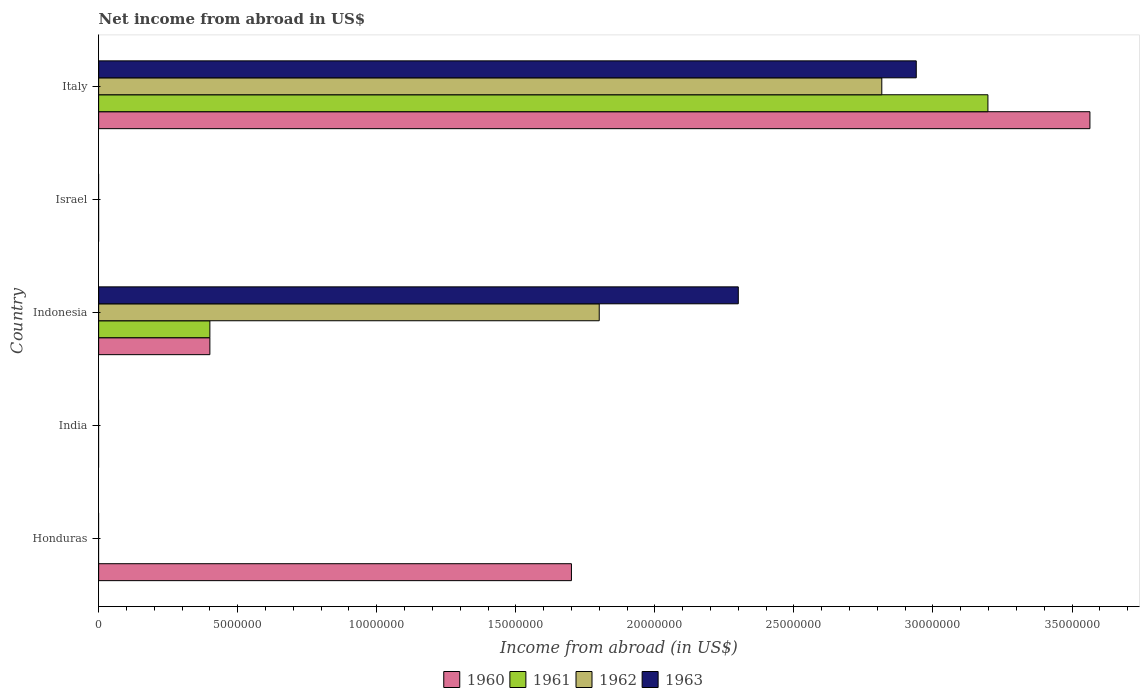Are the number of bars on each tick of the Y-axis equal?
Make the answer very short. No. How many bars are there on the 5th tick from the top?
Your answer should be very brief. 1. How many bars are there on the 1st tick from the bottom?
Your answer should be very brief. 1. What is the label of the 2nd group of bars from the top?
Offer a very short reply. Israel. In how many cases, is the number of bars for a given country not equal to the number of legend labels?
Ensure brevity in your answer.  3. What is the net income from abroad in 1961 in India?
Keep it short and to the point. 0. Across all countries, what is the maximum net income from abroad in 1963?
Make the answer very short. 2.94e+07. Across all countries, what is the minimum net income from abroad in 1961?
Make the answer very short. 0. In which country was the net income from abroad in 1960 maximum?
Ensure brevity in your answer.  Italy. What is the total net income from abroad in 1963 in the graph?
Provide a short and direct response. 5.24e+07. What is the difference between the net income from abroad in 1960 in India and the net income from abroad in 1963 in Indonesia?
Your response must be concise. -2.30e+07. What is the average net income from abroad in 1962 per country?
Provide a succinct answer. 9.23e+06. What is the difference between the net income from abroad in 1962 and net income from abroad in 1961 in Indonesia?
Your response must be concise. 1.40e+07. In how many countries, is the net income from abroad in 1963 greater than 11000000 US$?
Provide a short and direct response. 2. What is the difference between the highest and the second highest net income from abroad in 1960?
Your response must be concise. 1.86e+07. What is the difference between the highest and the lowest net income from abroad in 1961?
Make the answer very short. 3.20e+07. In how many countries, is the net income from abroad in 1960 greater than the average net income from abroad in 1960 taken over all countries?
Offer a very short reply. 2. Is the sum of the net income from abroad in 1960 in Honduras and Italy greater than the maximum net income from abroad in 1961 across all countries?
Make the answer very short. Yes. Is it the case that in every country, the sum of the net income from abroad in 1960 and net income from abroad in 1963 is greater than the net income from abroad in 1961?
Give a very brief answer. No. How many bars are there?
Provide a succinct answer. 9. How many countries are there in the graph?
Provide a succinct answer. 5. What is the difference between two consecutive major ticks on the X-axis?
Offer a very short reply. 5.00e+06. Are the values on the major ticks of X-axis written in scientific E-notation?
Provide a short and direct response. No. Does the graph contain grids?
Your response must be concise. No. Where does the legend appear in the graph?
Keep it short and to the point. Bottom center. How are the legend labels stacked?
Give a very brief answer. Horizontal. What is the title of the graph?
Give a very brief answer. Net income from abroad in US$. Does "2006" appear as one of the legend labels in the graph?
Make the answer very short. No. What is the label or title of the X-axis?
Your answer should be compact. Income from abroad (in US$). What is the Income from abroad (in US$) in 1960 in Honduras?
Your response must be concise. 1.70e+07. What is the Income from abroad (in US$) of 1961 in Honduras?
Provide a succinct answer. 0. What is the Income from abroad (in US$) of 1962 in Honduras?
Offer a very short reply. 0. What is the Income from abroad (in US$) in 1960 in Indonesia?
Your answer should be compact. 4.00e+06. What is the Income from abroad (in US$) in 1962 in Indonesia?
Offer a terse response. 1.80e+07. What is the Income from abroad (in US$) of 1963 in Indonesia?
Keep it short and to the point. 2.30e+07. What is the Income from abroad (in US$) in 1960 in Italy?
Your answer should be very brief. 3.56e+07. What is the Income from abroad (in US$) in 1961 in Italy?
Offer a terse response. 3.20e+07. What is the Income from abroad (in US$) of 1962 in Italy?
Ensure brevity in your answer.  2.82e+07. What is the Income from abroad (in US$) in 1963 in Italy?
Offer a terse response. 2.94e+07. Across all countries, what is the maximum Income from abroad (in US$) of 1960?
Your answer should be very brief. 3.56e+07. Across all countries, what is the maximum Income from abroad (in US$) in 1961?
Provide a short and direct response. 3.20e+07. Across all countries, what is the maximum Income from abroad (in US$) in 1962?
Provide a succinct answer. 2.82e+07. Across all countries, what is the maximum Income from abroad (in US$) of 1963?
Provide a succinct answer. 2.94e+07. Across all countries, what is the minimum Income from abroad (in US$) in 1960?
Provide a succinct answer. 0. Across all countries, what is the minimum Income from abroad (in US$) in 1961?
Offer a terse response. 0. Across all countries, what is the minimum Income from abroad (in US$) in 1962?
Offer a terse response. 0. What is the total Income from abroad (in US$) of 1960 in the graph?
Ensure brevity in your answer.  5.66e+07. What is the total Income from abroad (in US$) of 1961 in the graph?
Offer a terse response. 3.60e+07. What is the total Income from abroad (in US$) in 1962 in the graph?
Offer a terse response. 4.62e+07. What is the total Income from abroad (in US$) of 1963 in the graph?
Provide a succinct answer. 5.24e+07. What is the difference between the Income from abroad (in US$) of 1960 in Honduras and that in Indonesia?
Offer a terse response. 1.30e+07. What is the difference between the Income from abroad (in US$) in 1960 in Honduras and that in Italy?
Give a very brief answer. -1.86e+07. What is the difference between the Income from abroad (in US$) in 1960 in Indonesia and that in Italy?
Your answer should be very brief. -3.16e+07. What is the difference between the Income from abroad (in US$) of 1961 in Indonesia and that in Italy?
Offer a very short reply. -2.80e+07. What is the difference between the Income from abroad (in US$) in 1962 in Indonesia and that in Italy?
Offer a very short reply. -1.02e+07. What is the difference between the Income from abroad (in US$) in 1963 in Indonesia and that in Italy?
Your answer should be compact. -6.40e+06. What is the difference between the Income from abroad (in US$) in 1960 in Honduras and the Income from abroad (in US$) in 1961 in Indonesia?
Offer a very short reply. 1.30e+07. What is the difference between the Income from abroad (in US$) in 1960 in Honduras and the Income from abroad (in US$) in 1962 in Indonesia?
Provide a short and direct response. -1.00e+06. What is the difference between the Income from abroad (in US$) of 1960 in Honduras and the Income from abroad (in US$) of 1963 in Indonesia?
Keep it short and to the point. -6.00e+06. What is the difference between the Income from abroad (in US$) of 1960 in Honduras and the Income from abroad (in US$) of 1961 in Italy?
Keep it short and to the point. -1.50e+07. What is the difference between the Income from abroad (in US$) of 1960 in Honduras and the Income from abroad (in US$) of 1962 in Italy?
Ensure brevity in your answer.  -1.12e+07. What is the difference between the Income from abroad (in US$) in 1960 in Honduras and the Income from abroad (in US$) in 1963 in Italy?
Offer a very short reply. -1.24e+07. What is the difference between the Income from abroad (in US$) of 1960 in Indonesia and the Income from abroad (in US$) of 1961 in Italy?
Keep it short and to the point. -2.80e+07. What is the difference between the Income from abroad (in US$) in 1960 in Indonesia and the Income from abroad (in US$) in 1962 in Italy?
Your answer should be compact. -2.42e+07. What is the difference between the Income from abroad (in US$) of 1960 in Indonesia and the Income from abroad (in US$) of 1963 in Italy?
Offer a very short reply. -2.54e+07. What is the difference between the Income from abroad (in US$) of 1961 in Indonesia and the Income from abroad (in US$) of 1962 in Italy?
Offer a very short reply. -2.42e+07. What is the difference between the Income from abroad (in US$) of 1961 in Indonesia and the Income from abroad (in US$) of 1963 in Italy?
Keep it short and to the point. -2.54e+07. What is the difference between the Income from abroad (in US$) of 1962 in Indonesia and the Income from abroad (in US$) of 1963 in Italy?
Ensure brevity in your answer.  -1.14e+07. What is the average Income from abroad (in US$) in 1960 per country?
Offer a very short reply. 1.13e+07. What is the average Income from abroad (in US$) of 1961 per country?
Your answer should be very brief. 7.20e+06. What is the average Income from abroad (in US$) of 1962 per country?
Your answer should be very brief. 9.23e+06. What is the average Income from abroad (in US$) in 1963 per country?
Provide a short and direct response. 1.05e+07. What is the difference between the Income from abroad (in US$) in 1960 and Income from abroad (in US$) in 1962 in Indonesia?
Offer a terse response. -1.40e+07. What is the difference between the Income from abroad (in US$) of 1960 and Income from abroad (in US$) of 1963 in Indonesia?
Keep it short and to the point. -1.90e+07. What is the difference between the Income from abroad (in US$) in 1961 and Income from abroad (in US$) in 1962 in Indonesia?
Provide a short and direct response. -1.40e+07. What is the difference between the Income from abroad (in US$) in 1961 and Income from abroad (in US$) in 1963 in Indonesia?
Your answer should be compact. -1.90e+07. What is the difference between the Income from abroad (in US$) of 1962 and Income from abroad (in US$) of 1963 in Indonesia?
Your answer should be compact. -5.00e+06. What is the difference between the Income from abroad (in US$) of 1960 and Income from abroad (in US$) of 1961 in Italy?
Ensure brevity in your answer.  3.67e+06. What is the difference between the Income from abroad (in US$) of 1960 and Income from abroad (in US$) of 1962 in Italy?
Your answer should be very brief. 7.48e+06. What is the difference between the Income from abroad (in US$) in 1960 and Income from abroad (in US$) in 1963 in Italy?
Ensure brevity in your answer.  6.24e+06. What is the difference between the Income from abroad (in US$) in 1961 and Income from abroad (in US$) in 1962 in Italy?
Provide a short and direct response. 3.82e+06. What is the difference between the Income from abroad (in US$) in 1961 and Income from abroad (in US$) in 1963 in Italy?
Your answer should be compact. 2.58e+06. What is the difference between the Income from abroad (in US$) of 1962 and Income from abroad (in US$) of 1963 in Italy?
Give a very brief answer. -1.24e+06. What is the ratio of the Income from abroad (in US$) of 1960 in Honduras to that in Indonesia?
Your answer should be compact. 4.25. What is the ratio of the Income from abroad (in US$) of 1960 in Honduras to that in Italy?
Ensure brevity in your answer.  0.48. What is the ratio of the Income from abroad (in US$) of 1960 in Indonesia to that in Italy?
Offer a very short reply. 0.11. What is the ratio of the Income from abroad (in US$) of 1961 in Indonesia to that in Italy?
Offer a very short reply. 0.13. What is the ratio of the Income from abroad (in US$) of 1962 in Indonesia to that in Italy?
Provide a succinct answer. 0.64. What is the ratio of the Income from abroad (in US$) of 1963 in Indonesia to that in Italy?
Provide a short and direct response. 0.78. What is the difference between the highest and the second highest Income from abroad (in US$) of 1960?
Make the answer very short. 1.86e+07. What is the difference between the highest and the lowest Income from abroad (in US$) of 1960?
Offer a very short reply. 3.56e+07. What is the difference between the highest and the lowest Income from abroad (in US$) in 1961?
Keep it short and to the point. 3.20e+07. What is the difference between the highest and the lowest Income from abroad (in US$) of 1962?
Offer a very short reply. 2.82e+07. What is the difference between the highest and the lowest Income from abroad (in US$) of 1963?
Provide a succinct answer. 2.94e+07. 